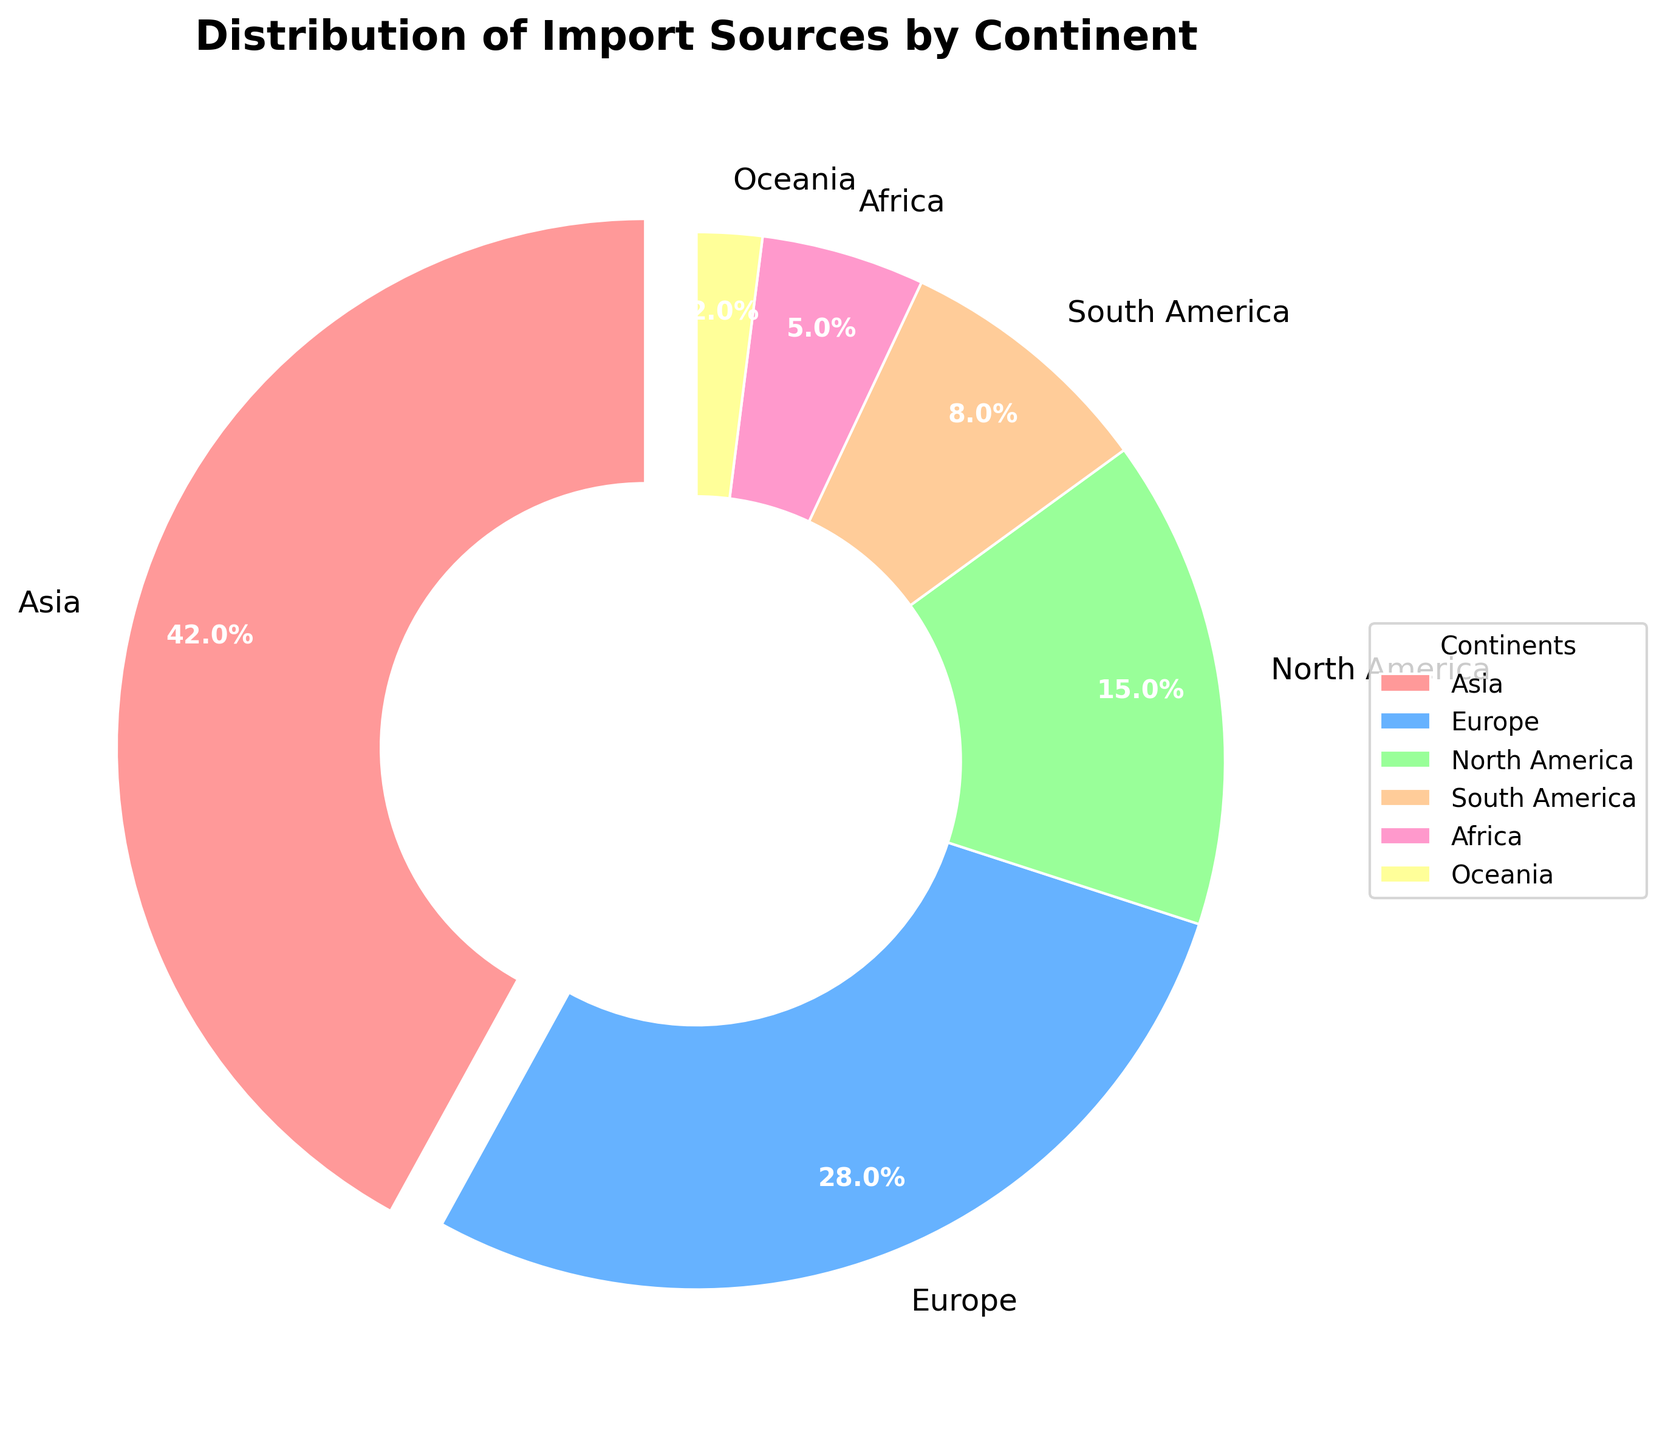Which continent contributes the most to the import sources? Identify the largest segment or slice in the pie chart. The biggest slice represents Asia with a percentage of 42%.
Answer: Asia What percentage of import sources does Europe contribute? Find the slice labeled Europe and check the percentage value written on it, which is 28%.
Answer: 28% How does the contribution of North America compare to that of South America? Locate the slices for North America and South America and compare their percentages. North America contributes 15%, while South America contributes 8%, thus North America's contribution is higher.
Answer: North America contributes more What are the combined contributions of Africa and Oceania? Find the slices for Africa and Oceania and add their percentages: 5% from Africa and 2% from Oceania. 5 + 2 = 7%.
Answer: 7% Which color represents Europe in the pie chart? Look at the legend associated with the pie chart to identify the color corresponding to Europe. The colors, in order, should be Pink for Asia, Light blue for Europe, etc.
Answer: Light blue How much greater is Asia's contribution compared to Europe’s? Subtract Europe’s percentage from Asia's: 42% - 28% = 14%.
Answer: 14% If you add the contributions of continents from the least contributive to the most until they make more than Asia’s contribution alone, which continents would be included? Start with the smallest percentage and keep adding until it exceeds 42%. Oceania (2%) + Africa (5%) + South America (8%) + North America (15%) add up to 30%. Adding Europe next (28%), the sum becomes 58%, which exceeds Asia's contribution.
Answer: Oceania, Africa, South America, North America, and Europe Which two continents combined contribute the same percentage as Europe alone? Find pairs of continents whose combined percentages equal Europe’s 28%. Africa (5%) + South America (8%) = 13%, Asia (42%) + Oceania (2%) = 44%, and so forth. The correct pairs are North America (15%) + South America (8%) = 23%, which is incorrect. Another correction pair is Oceania (2%) + North America (15%) = 17%, which is incorrect.
Answer: None What is the visual attribute that differentiates the slice representing Asia from all other continents? The pie chart uses an "explode" parameter, which separates the Asia slice slightly from the rest of the pie.
Answer: The slice is separated from the rest How much of the chart is dedicated to continents other than Asia and Europe? Subtract the sum of Asia's and Europe’s contributions from 100%. 100% - (42% + 28%) = 30%.
Answer: 30% 